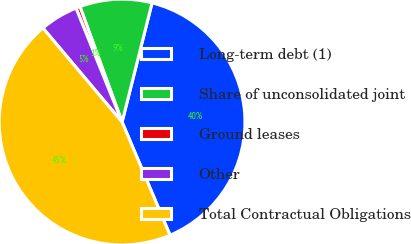Convert chart. <chart><loc_0><loc_0><loc_500><loc_500><pie_chart><fcel>Long-term debt (1)<fcel>Share of unconsolidated joint<fcel>Ground leases<fcel>Other<fcel>Total Contractual Obligations<nl><fcel>39.69%<fcel>9.49%<fcel>0.55%<fcel>5.02%<fcel>45.24%<nl></chart> 